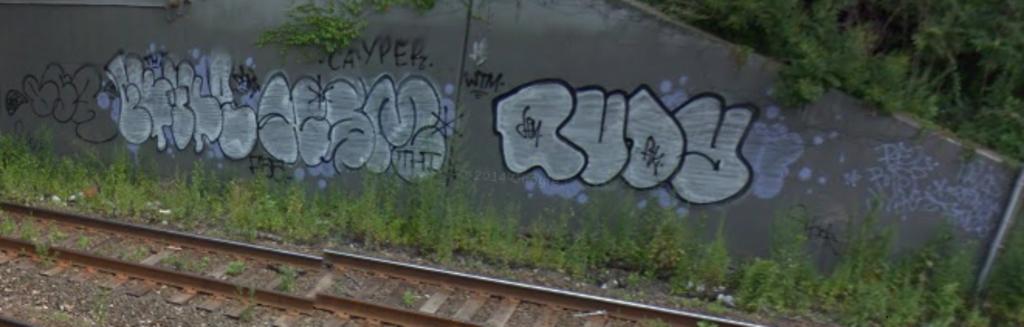What is most likely the name of the person who did the graffiti on the right?
Your answer should be very brief. Rudy. What does the top tag say?
Make the answer very short. Cayper. 